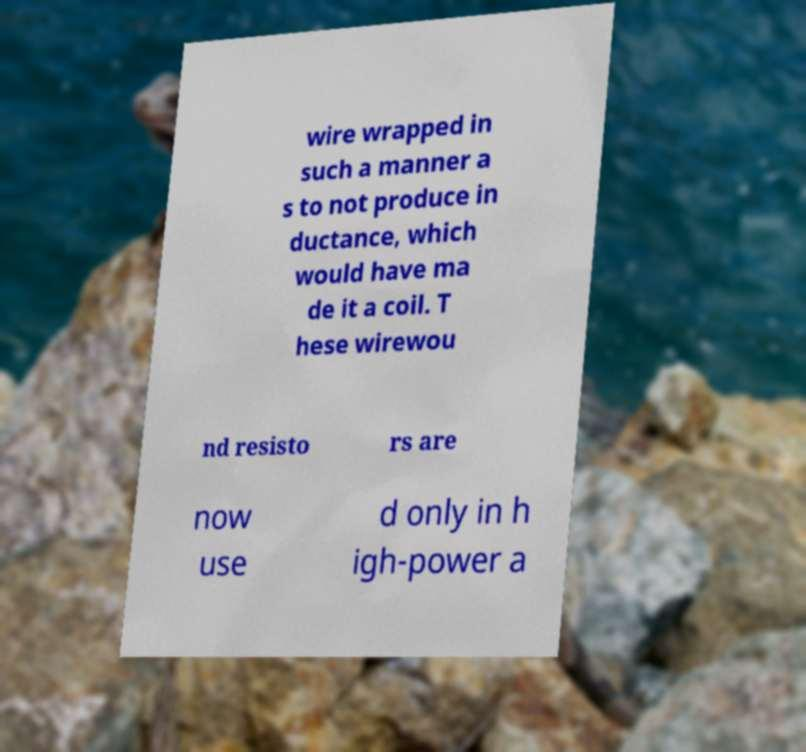For documentation purposes, I need the text within this image transcribed. Could you provide that? wire wrapped in such a manner a s to not produce in ductance, which would have ma de it a coil. T hese wirewou nd resisto rs are now use d only in h igh-power a 